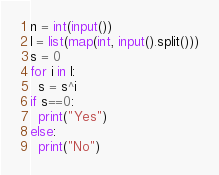Convert code to text. <code><loc_0><loc_0><loc_500><loc_500><_Python_>n = int(input())
l = list(map(int, input().split()))
s = 0
for i in l:
  s = s^i
if s==0:
  print("Yes")
else:
  print("No")</code> 